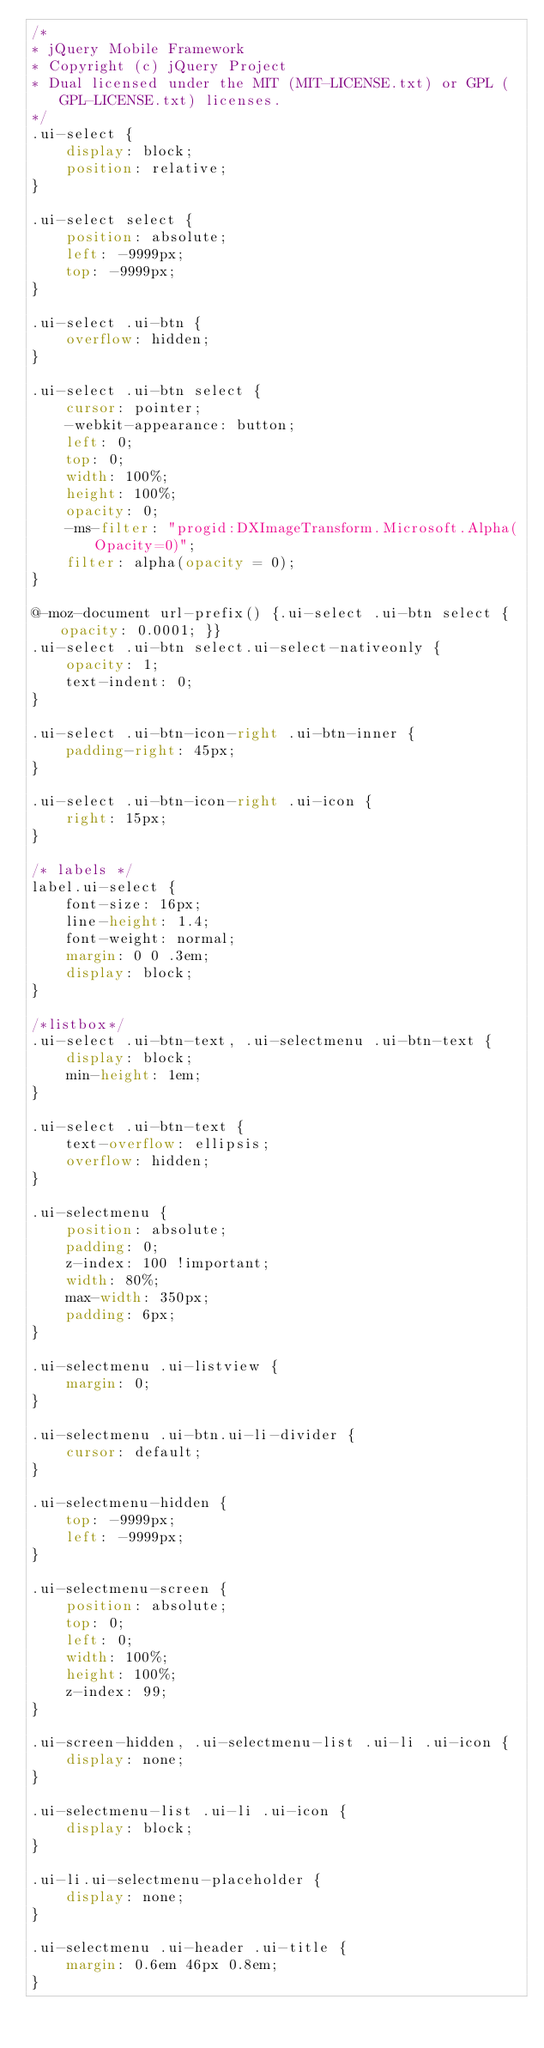<code> <loc_0><loc_0><loc_500><loc_500><_CSS_>/*
* jQuery Mobile Framework
* Copyright (c) jQuery Project
* Dual licensed under the MIT (MIT-LICENSE.txt) or GPL (GPL-LICENSE.txt) licenses.
*/
.ui-select {
    display: block;
    position: relative;
}

.ui-select select {
    position: absolute;
    left: -9999px;
    top: -9999px;
}

.ui-select .ui-btn {
    overflow: hidden;
}

.ui-select .ui-btn select {
    cursor: pointer;
    -webkit-appearance: button;
    left: 0;
    top: 0;
    width: 100%;
    height: 100%;
    opacity: 0;
    -ms-filter: "progid:DXImageTransform.Microsoft.Alpha(Opacity=0)";
    filter: alpha(opacity = 0);
}

@-moz-document url-prefix() {.ui-select .ui-btn select { opacity: 0.0001; }}
.ui-select .ui-btn select.ui-select-nativeonly {
    opacity: 1;
    text-indent: 0;
}

.ui-select .ui-btn-icon-right .ui-btn-inner {
    padding-right: 45px;
}

.ui-select .ui-btn-icon-right .ui-icon {
    right: 15px;
}

/* labels */
label.ui-select {
    font-size: 16px;
    line-height: 1.4;
    font-weight: normal;
    margin: 0 0 .3em;
    display: block;
}

/*listbox*/
.ui-select .ui-btn-text, .ui-selectmenu .ui-btn-text {
    display: block;
    min-height: 1em;
}

.ui-select .ui-btn-text {
    text-overflow: ellipsis;
    overflow: hidden;
}

.ui-selectmenu {
    position: absolute;
    padding: 0;
    z-index: 100 !important;
    width: 80%;
    max-width: 350px;
    padding: 6px;
}

.ui-selectmenu .ui-listview {
    margin: 0;
}

.ui-selectmenu .ui-btn.ui-li-divider {
    cursor: default;
}

.ui-selectmenu-hidden {
    top: -9999px;
    left: -9999px;
}

.ui-selectmenu-screen {
    position: absolute;
    top: 0;
    left: 0;
    width: 100%;
    height: 100%;
    z-index: 99;
}

.ui-screen-hidden, .ui-selectmenu-list .ui-li .ui-icon {
    display: none;
}

.ui-selectmenu-list .ui-li .ui-icon {
    display: block;
}

.ui-li.ui-selectmenu-placeholder {
    display: none;
}

.ui-selectmenu .ui-header .ui-title {
    margin: 0.6em 46px 0.8em;
}
</code> 